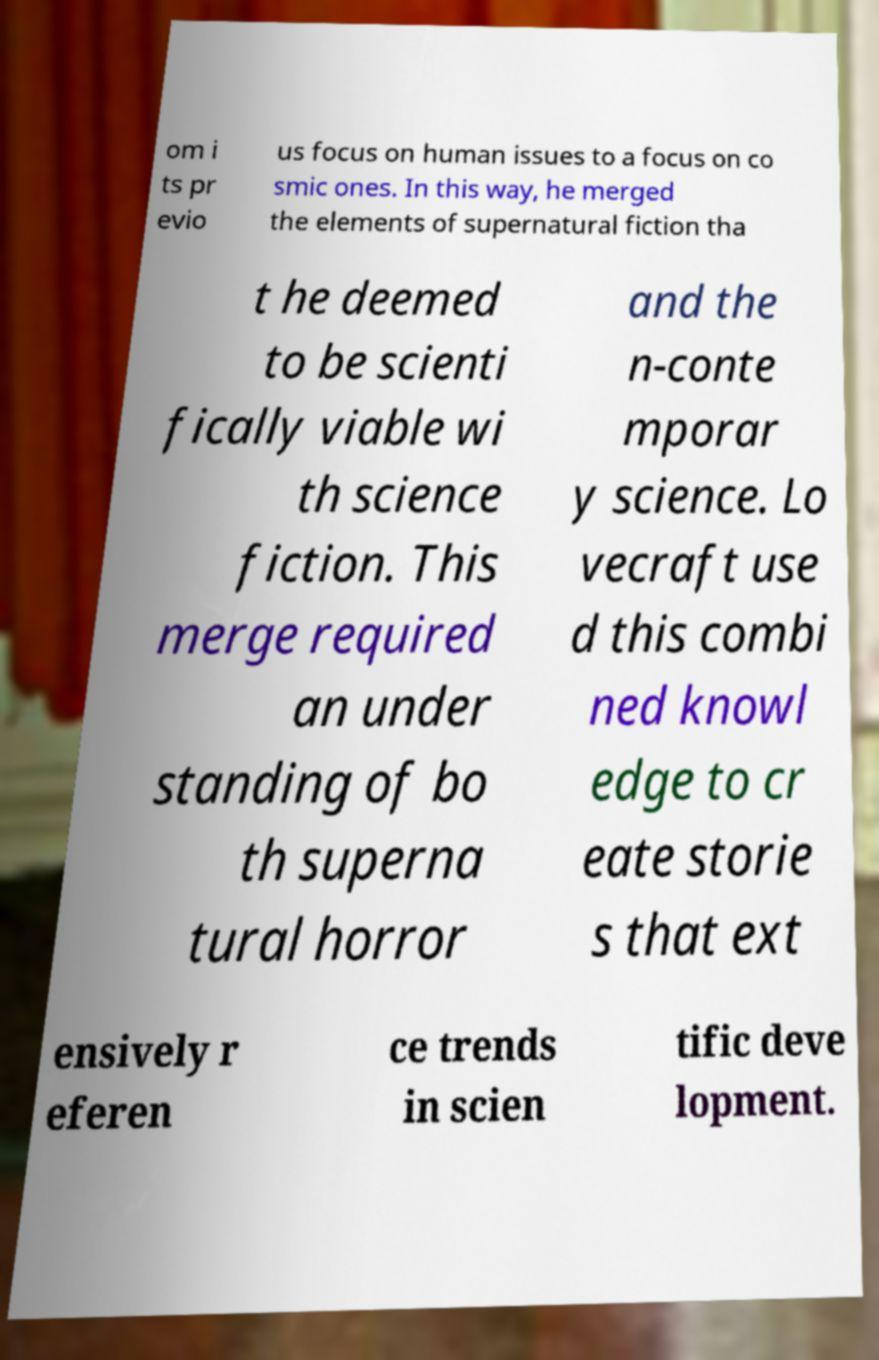I need the written content from this picture converted into text. Can you do that? om i ts pr evio us focus on human issues to a focus on co smic ones. In this way, he merged the elements of supernatural fiction tha t he deemed to be scienti fically viable wi th science fiction. This merge required an under standing of bo th superna tural horror and the n-conte mporar y science. Lo vecraft use d this combi ned knowl edge to cr eate storie s that ext ensively r eferen ce trends in scien tific deve lopment. 